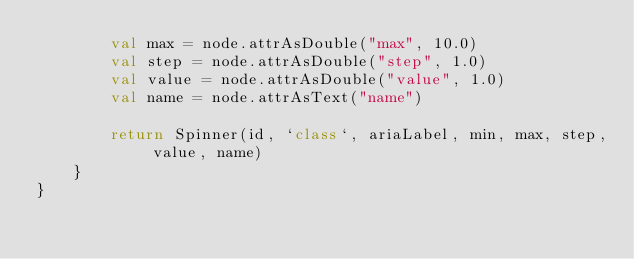Convert code to text. <code><loc_0><loc_0><loc_500><loc_500><_Kotlin_>        val max = node.attrAsDouble("max", 10.0)
        val step = node.attrAsDouble("step", 1.0)
        val value = node.attrAsDouble("value", 1.0)
        val name = node.attrAsText("name")

        return Spinner(id, `class`, ariaLabel, min, max, step, value, name)
    }
}</code> 